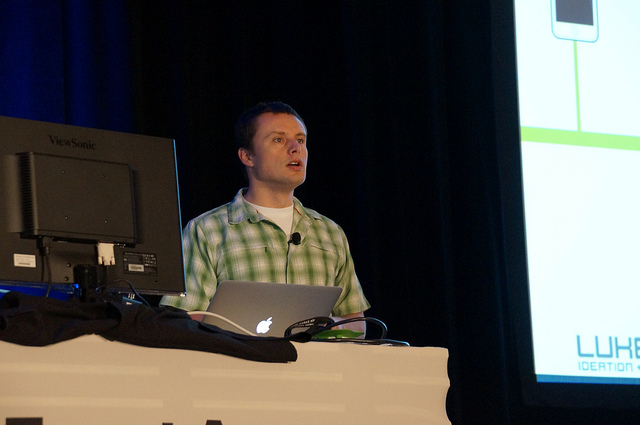Please transcribe the text information in this image. LUH IDERTION 